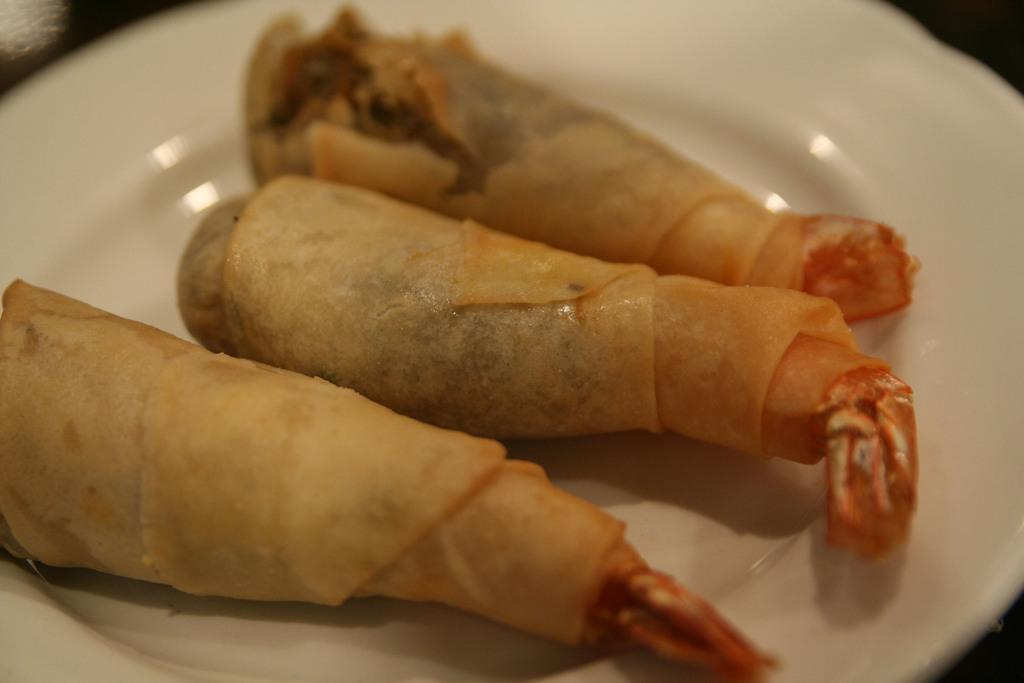What is on the plate that is visible in the image? There is food placed on a plate in the image. What can be seen beneath the plate in the image? The plate is placed on a black color surface. What type of pancake is being served by the doctor in the image? There is no doctor or pancake present in the image. The image only shows food on a plate placed on a black surface. 